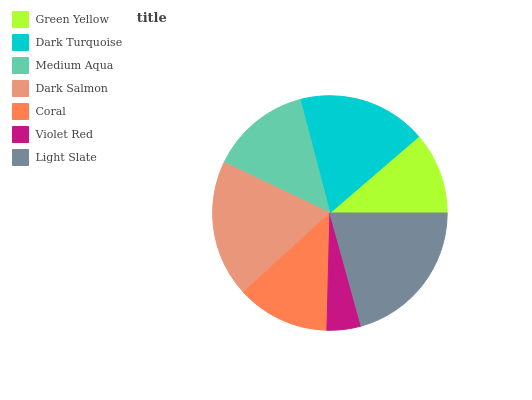Is Violet Red the minimum?
Answer yes or no. Yes. Is Light Slate the maximum?
Answer yes or no. Yes. Is Dark Turquoise the minimum?
Answer yes or no. No. Is Dark Turquoise the maximum?
Answer yes or no. No. Is Dark Turquoise greater than Green Yellow?
Answer yes or no. Yes. Is Green Yellow less than Dark Turquoise?
Answer yes or no. Yes. Is Green Yellow greater than Dark Turquoise?
Answer yes or no. No. Is Dark Turquoise less than Green Yellow?
Answer yes or no. No. Is Medium Aqua the high median?
Answer yes or no. Yes. Is Medium Aqua the low median?
Answer yes or no. Yes. Is Coral the high median?
Answer yes or no. No. Is Green Yellow the low median?
Answer yes or no. No. 